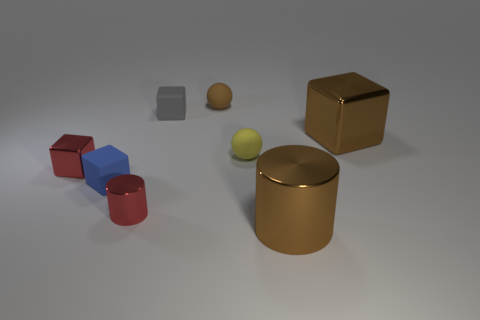Add 2 matte balls. How many objects exist? 10 Subtract all balls. How many objects are left? 6 Add 6 brown blocks. How many brown blocks are left? 7 Add 6 blue cubes. How many blue cubes exist? 7 Subtract 0 gray spheres. How many objects are left? 8 Subtract all tiny shiny things. Subtract all large brown things. How many objects are left? 4 